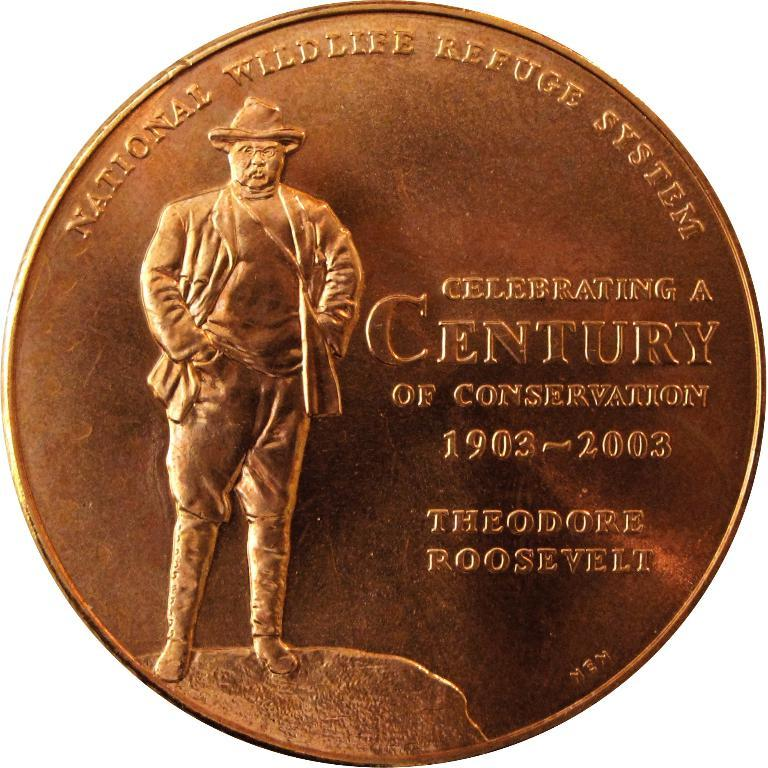<image>
Give a short and clear explanation of the subsequent image. The bronze coin celebrates a century of conservation. 